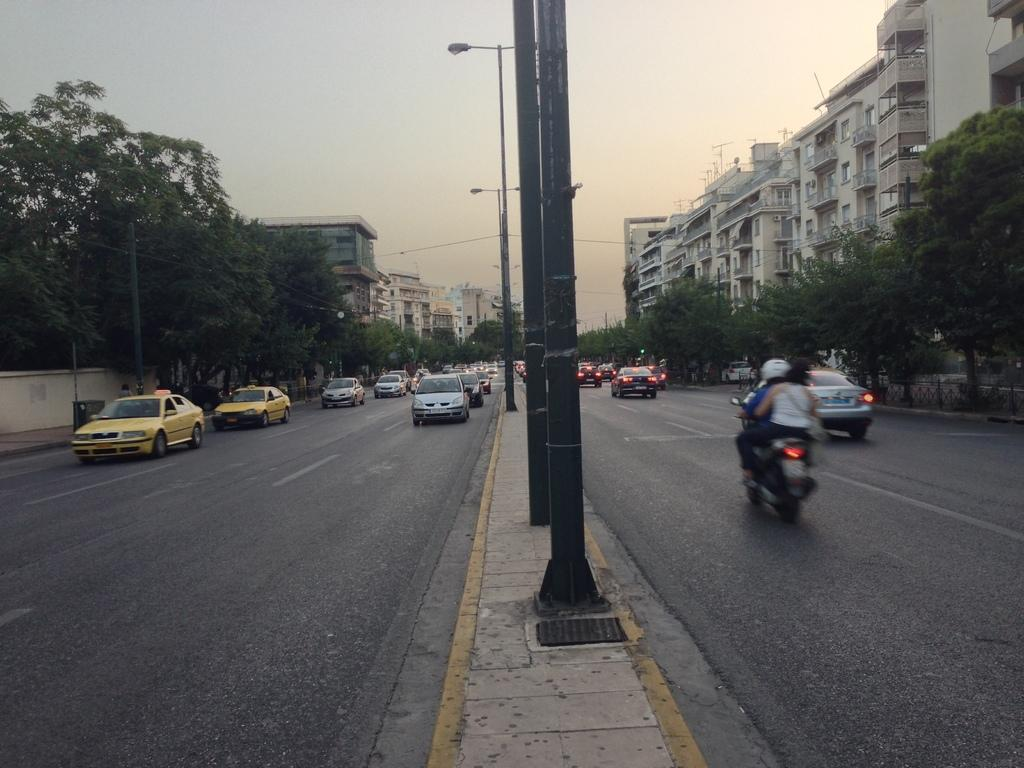What can be seen moving on the road in the image? There are vehicles on the road in the image. What structures are present alongside the road in the image? There are light poles in the image. What type of vegetation is visible in the image? There are trees with green color in the image. What type of man-made structures can be seen in the image? There are buildings in the image. What is the color of the sky in the image? The sky appears to be white in color in the image. How many hands are visible holding a whip in the image? There are no hands or whips present in the image. What type of slip can be seen on the road in the image? There is no slip visible on the road in the image. 